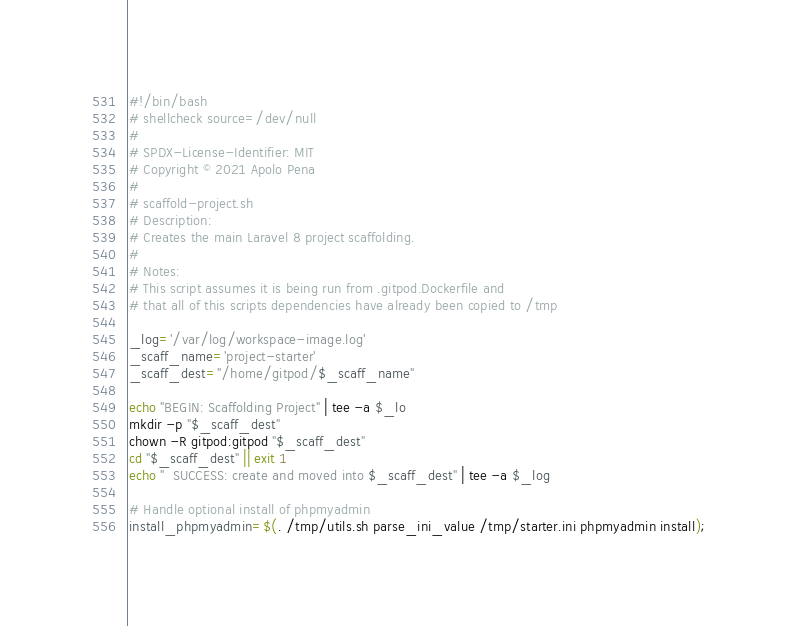<code> <loc_0><loc_0><loc_500><loc_500><_Bash_>#!/bin/bash
# shellcheck source=/dev/null
#
# SPDX-License-Identifier: MIT
# Copyright © 2021 Apolo Pena
#
# scaffold-project.sh
# Description:
# Creates the main Laravel 8 project scaffolding.
#
# Notes:
# This script assumes it is being run from .gitpod.Dockerfile and
# that all of this scripts dependencies have already been copied to /tmp

_log='/var/log/workspace-image.log'
_scaff_name='project-starter'
_scaff_dest="/home/gitpod/$_scaff_name"

echo "BEGIN: Scaffolding Project" | tee -a $_lo
mkdir -p "$_scaff_dest"
chown -R gitpod:gitpod "$_scaff_dest"
cd "$_scaff_dest" || exit 1
echo "  SUCCESS: create and moved into $_scaff_dest" | tee -a $_log

# Handle optional install of phpmyadmin
install_phpmyadmin=$(. /tmp/utils.sh parse_ini_value /tmp/starter.ini phpmyadmin install);</code> 